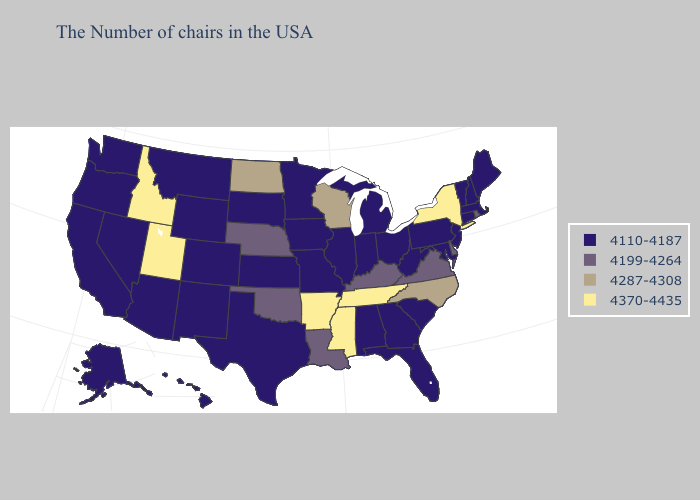What is the highest value in the South ?
Answer briefly. 4370-4435. Among the states that border Minnesota , which have the lowest value?
Short answer required. Iowa, South Dakota. Does Oregon have a lower value than Nevada?
Keep it brief. No. Does New York have the highest value in the Northeast?
Answer briefly. Yes. Does Florida have the lowest value in the USA?
Concise answer only. Yes. Name the states that have a value in the range 4110-4187?
Keep it brief. Maine, Massachusetts, New Hampshire, Vermont, Connecticut, New Jersey, Maryland, Pennsylvania, South Carolina, West Virginia, Ohio, Florida, Georgia, Michigan, Indiana, Alabama, Illinois, Missouri, Minnesota, Iowa, Kansas, Texas, South Dakota, Wyoming, Colorado, New Mexico, Montana, Arizona, Nevada, California, Washington, Oregon, Alaska, Hawaii. What is the value of Missouri?
Quick response, please. 4110-4187. Which states have the lowest value in the South?
Answer briefly. Maryland, South Carolina, West Virginia, Florida, Georgia, Alabama, Texas. What is the lowest value in the South?
Short answer required. 4110-4187. Name the states that have a value in the range 4370-4435?
Keep it brief. New York, Tennessee, Mississippi, Arkansas, Utah, Idaho. What is the value of Nebraska?
Quick response, please. 4199-4264. Which states have the lowest value in the USA?
Quick response, please. Maine, Massachusetts, New Hampshire, Vermont, Connecticut, New Jersey, Maryland, Pennsylvania, South Carolina, West Virginia, Ohio, Florida, Georgia, Michigan, Indiana, Alabama, Illinois, Missouri, Minnesota, Iowa, Kansas, Texas, South Dakota, Wyoming, Colorado, New Mexico, Montana, Arizona, Nevada, California, Washington, Oregon, Alaska, Hawaii. What is the value of Connecticut?
Give a very brief answer. 4110-4187. Does Virginia have the lowest value in the South?
Concise answer only. No. Name the states that have a value in the range 4370-4435?
Write a very short answer. New York, Tennessee, Mississippi, Arkansas, Utah, Idaho. 